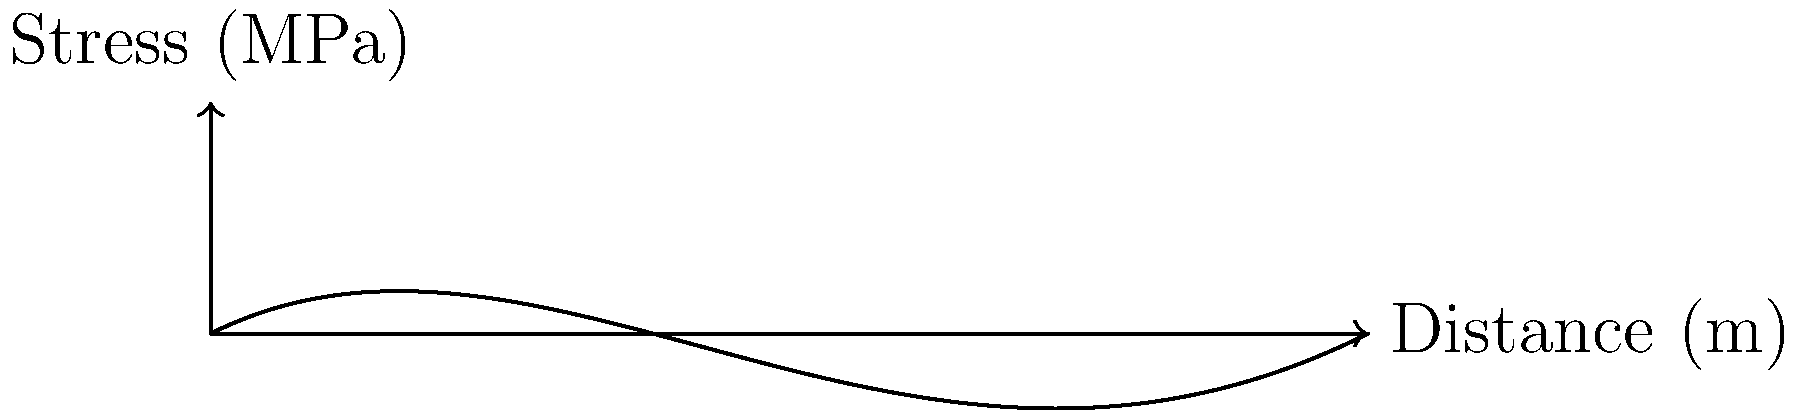As a business administration professor with expertise in IT integration, you're collaborating on a project involving structural analysis software for a construction company. The graph shows the stress distribution in a concrete beam under a specific load condition. What type of stress distribution does this curve most likely represent, and how might this information be valuable for IT integration in construction project management? To answer this question, let's analyze the graph step-by-step:

1. Shape of the curve: The curve is non-linear and asymmetrical, with higher stress values at one end and gradually decreasing towards the other end.

2. Stress distribution in beams: In a typical beam under bending, the stress distribution varies along the length of the beam. The maximum stress usually occurs at the point of maximum bending moment.

3. Identifying the stress type: The curve resembles a bending stress distribution in a cantilever beam with a point load at the free end. The stress is highest at the fixed end (left side of the graph) and decreases towards the free end (right side).

4. IT integration perspective: This type of stress analysis is crucial for:
   a) Structural design optimization
   b) Real-time monitoring of building structures
   c) Predictive maintenance
   d) Building Information Modeling (BIM) integration

5. Value for construction project management:
   a) Risk assessment: Identifying potential weak points in structures
   b) Resource allocation: Optimizing material usage based on stress distribution
   c) Schedule optimization: Prioritizing critical structural elements
   d) Cost estimation: More accurate budgeting based on detailed structural analysis

6. IT integration opportunities:
   a) Implementing cloud-based structural analysis tools
   b) Developing IoT sensors for real-time stress monitoring
   c) Creating data visualization dashboards for project managers
   d) Integrating stress analysis data with other project management software
Answer: Bending stress distribution in a cantilever beam; valuable for risk assessment, resource allocation, schedule optimization, and cost estimation in construction project management through IT integration. 